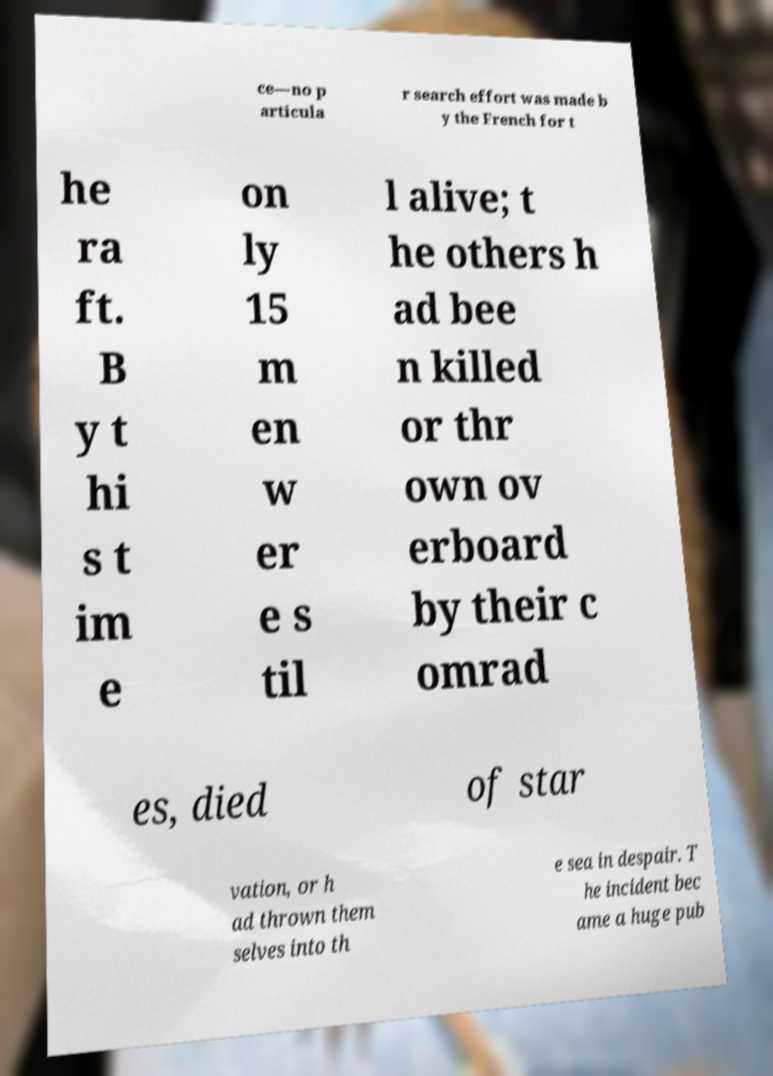I need the written content from this picture converted into text. Can you do that? ce—no p articula r search effort was made b y the French for t he ra ft. B y t hi s t im e on ly 15 m en w er e s til l alive; t he others h ad bee n killed or thr own ov erboard by their c omrad es, died of star vation, or h ad thrown them selves into th e sea in despair. T he incident bec ame a huge pub 